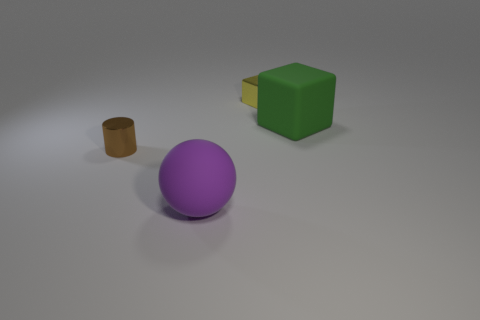Add 4 small brown objects. How many objects exist? 8 Subtract all balls. How many objects are left? 3 Subtract all small brown cylinders. Subtract all big green matte things. How many objects are left? 2 Add 1 small objects. How many small objects are left? 3 Add 4 big balls. How many big balls exist? 5 Subtract 0 yellow spheres. How many objects are left? 4 